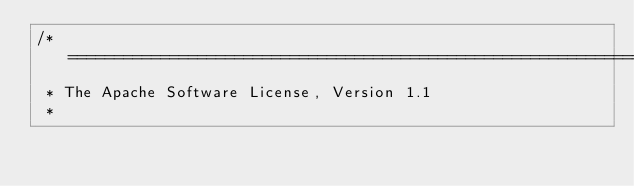Convert code to text. <code><loc_0><loc_0><loc_500><loc_500><_Java_>/* ====================================================================
 * The Apache Software License, Version 1.1
 *</code> 